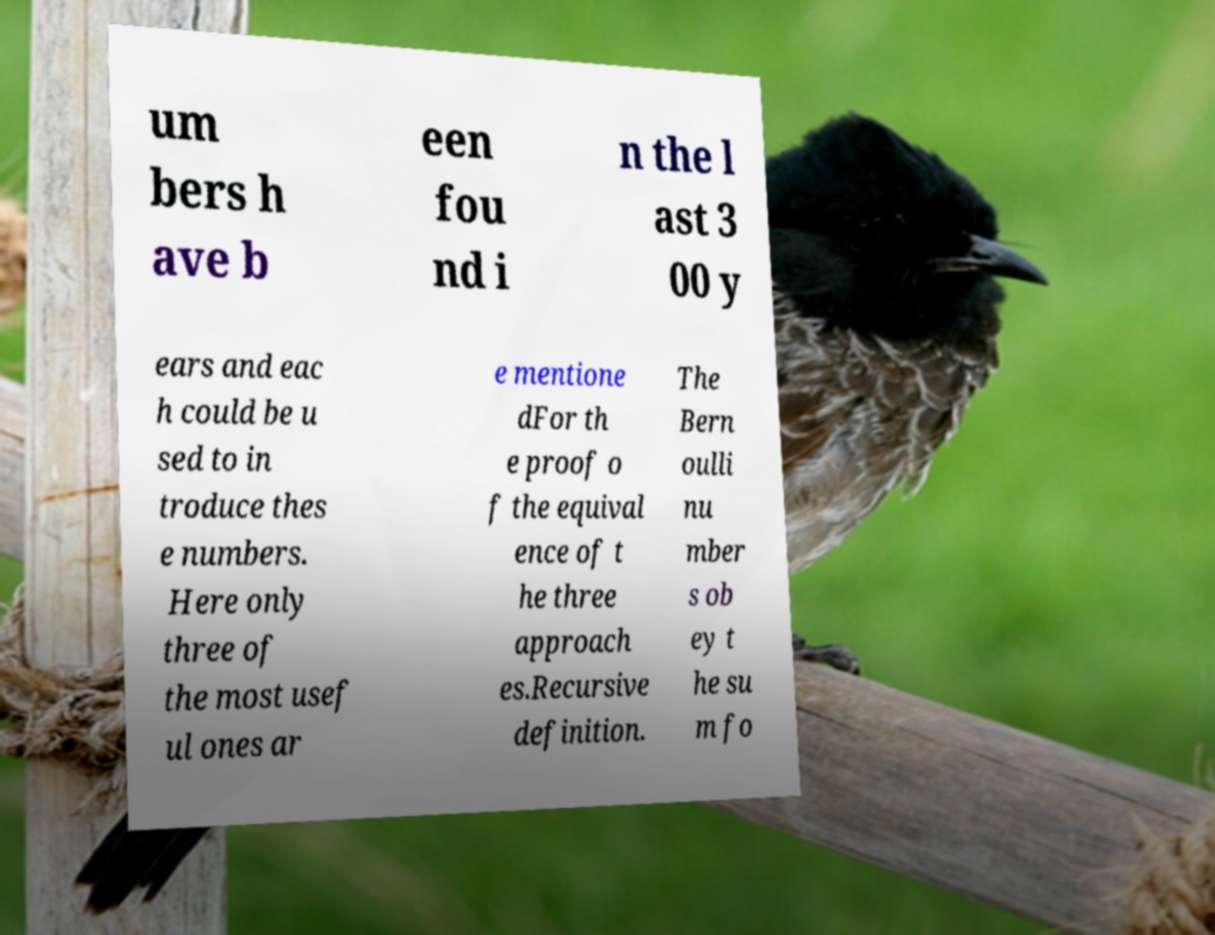Please read and relay the text visible in this image. What does it say? um bers h ave b een fou nd i n the l ast 3 00 y ears and eac h could be u sed to in troduce thes e numbers. Here only three of the most usef ul ones ar e mentione dFor th e proof o f the equival ence of t he three approach es.Recursive definition. The Bern oulli nu mber s ob ey t he su m fo 